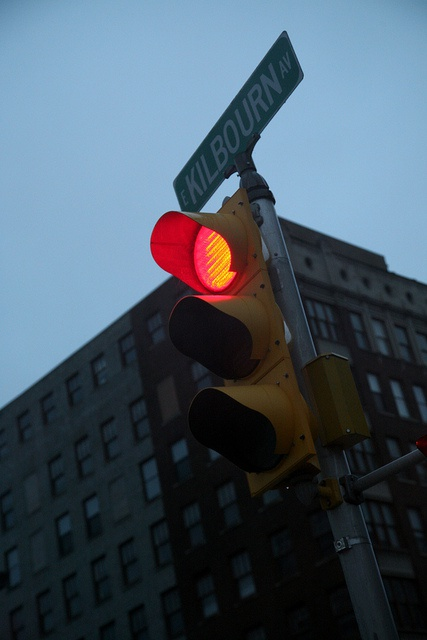Describe the objects in this image and their specific colors. I can see a traffic light in gray, black, maroon, and brown tones in this image. 